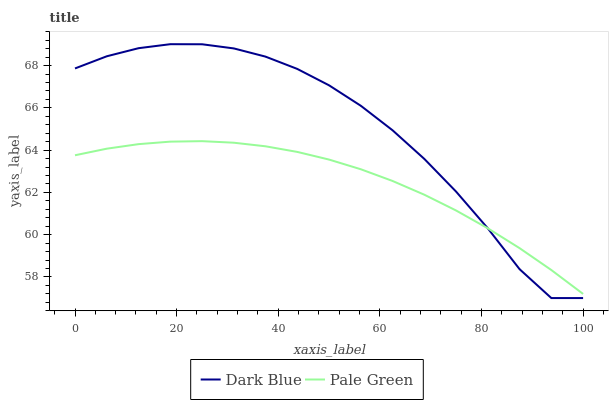Does Pale Green have the maximum area under the curve?
Answer yes or no. No. Is Pale Green the roughest?
Answer yes or no. No. Does Pale Green have the lowest value?
Answer yes or no. No. Does Pale Green have the highest value?
Answer yes or no. No. 